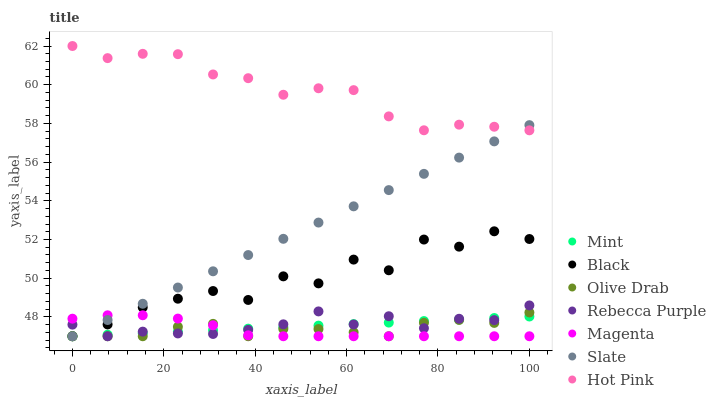Does Magenta have the minimum area under the curve?
Answer yes or no. Yes. Does Hot Pink have the maximum area under the curve?
Answer yes or no. Yes. Does Black have the minimum area under the curve?
Answer yes or no. No. Does Black have the maximum area under the curve?
Answer yes or no. No. Is Mint the smoothest?
Answer yes or no. Yes. Is Black the roughest?
Answer yes or no. Yes. Is Hot Pink the smoothest?
Answer yes or no. No. Is Hot Pink the roughest?
Answer yes or no. No. Does Slate have the lowest value?
Answer yes or no. Yes. Does Hot Pink have the lowest value?
Answer yes or no. No. Does Hot Pink have the highest value?
Answer yes or no. Yes. Does Black have the highest value?
Answer yes or no. No. Is Mint less than Hot Pink?
Answer yes or no. Yes. Is Hot Pink greater than Magenta?
Answer yes or no. Yes. Does Black intersect Magenta?
Answer yes or no. Yes. Is Black less than Magenta?
Answer yes or no. No. Is Black greater than Magenta?
Answer yes or no. No. Does Mint intersect Hot Pink?
Answer yes or no. No. 